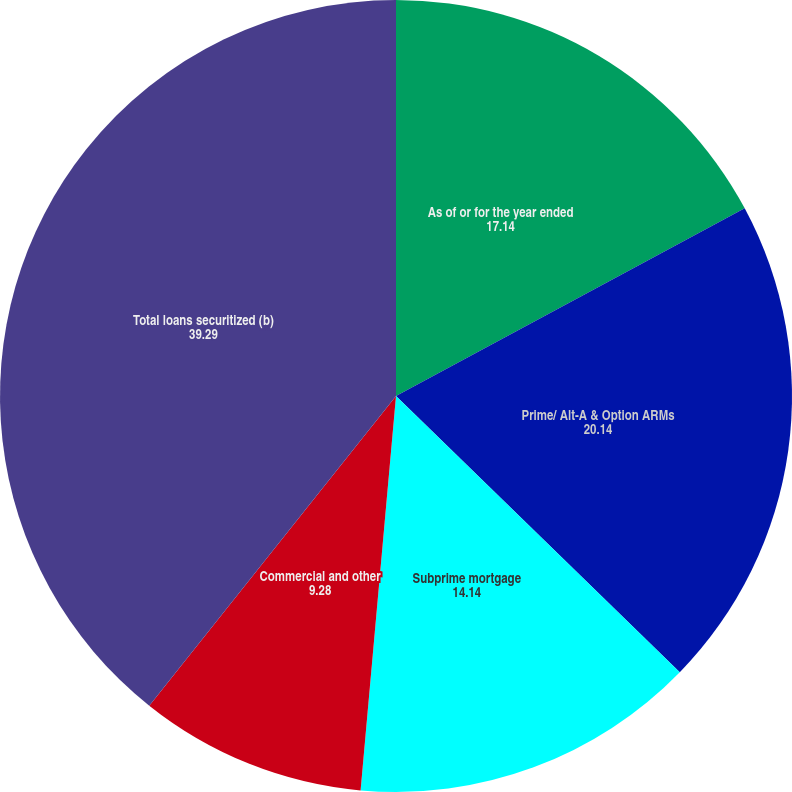Convert chart to OTSL. <chart><loc_0><loc_0><loc_500><loc_500><pie_chart><fcel>As of or for the year ended<fcel>Prime/ Alt-A & Option ARMs<fcel>Subprime mortgage<fcel>Commercial and other<fcel>Total loans securitized (b)<nl><fcel>17.14%<fcel>20.14%<fcel>14.14%<fcel>9.28%<fcel>39.29%<nl></chart> 